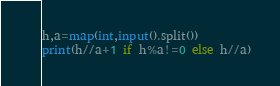Convert code to text. <code><loc_0><loc_0><loc_500><loc_500><_Python_>h,a=map(int,input().split())
print(h//a+1 if h%a!=0 else h//a)</code> 